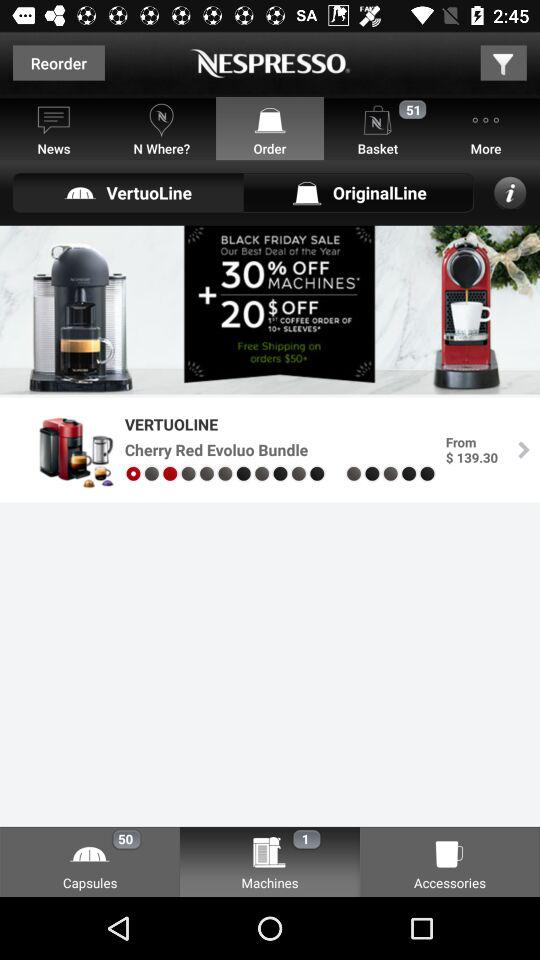What is the price of the "VERTUOLINE Cherry Red Evoluo Bundle"? The price of the "VERTUOLINE Cherry Red Evoluo Bundle" starts from $139.30. 